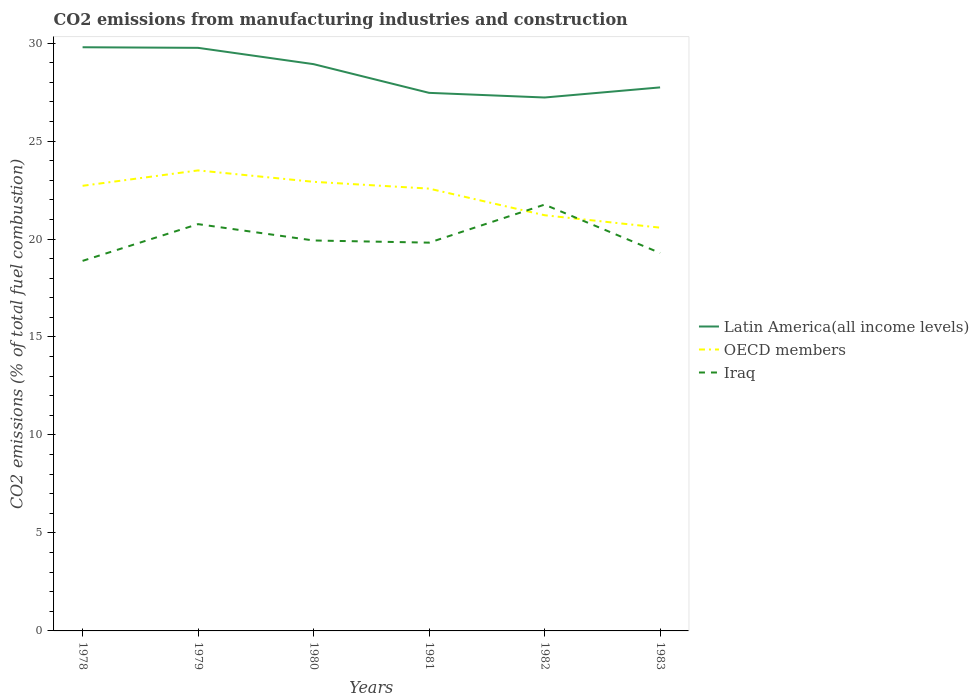Is the number of lines equal to the number of legend labels?
Keep it short and to the point. Yes. Across all years, what is the maximum amount of CO2 emitted in Iraq?
Offer a terse response. 18.89. In which year was the amount of CO2 emitted in Latin America(all income levels) maximum?
Give a very brief answer. 1982. What is the total amount of CO2 emitted in Latin America(all income levels) in the graph?
Provide a short and direct response. 0.83. What is the difference between the highest and the second highest amount of CO2 emitted in OECD members?
Offer a very short reply. 2.92. Is the amount of CO2 emitted in Latin America(all income levels) strictly greater than the amount of CO2 emitted in Iraq over the years?
Provide a short and direct response. No. How many years are there in the graph?
Provide a short and direct response. 6. How many legend labels are there?
Offer a very short reply. 3. How are the legend labels stacked?
Keep it short and to the point. Vertical. What is the title of the graph?
Your answer should be compact. CO2 emissions from manufacturing industries and construction. Does "St. Lucia" appear as one of the legend labels in the graph?
Your answer should be compact. No. What is the label or title of the X-axis?
Offer a terse response. Years. What is the label or title of the Y-axis?
Offer a very short reply. CO2 emissions (% of total fuel combustion). What is the CO2 emissions (% of total fuel combustion) of Latin America(all income levels) in 1978?
Your response must be concise. 29.79. What is the CO2 emissions (% of total fuel combustion) in OECD members in 1978?
Your answer should be compact. 22.72. What is the CO2 emissions (% of total fuel combustion) in Iraq in 1978?
Your answer should be compact. 18.89. What is the CO2 emissions (% of total fuel combustion) of Latin America(all income levels) in 1979?
Your answer should be very brief. 29.76. What is the CO2 emissions (% of total fuel combustion) of OECD members in 1979?
Provide a short and direct response. 23.5. What is the CO2 emissions (% of total fuel combustion) of Iraq in 1979?
Ensure brevity in your answer.  20.76. What is the CO2 emissions (% of total fuel combustion) in Latin America(all income levels) in 1980?
Make the answer very short. 28.92. What is the CO2 emissions (% of total fuel combustion) in OECD members in 1980?
Your response must be concise. 22.92. What is the CO2 emissions (% of total fuel combustion) of Iraq in 1980?
Keep it short and to the point. 19.93. What is the CO2 emissions (% of total fuel combustion) in Latin America(all income levels) in 1981?
Ensure brevity in your answer.  27.46. What is the CO2 emissions (% of total fuel combustion) in OECD members in 1981?
Provide a succinct answer. 22.57. What is the CO2 emissions (% of total fuel combustion) of Iraq in 1981?
Give a very brief answer. 19.82. What is the CO2 emissions (% of total fuel combustion) in Latin America(all income levels) in 1982?
Keep it short and to the point. 27.22. What is the CO2 emissions (% of total fuel combustion) of OECD members in 1982?
Your response must be concise. 21.21. What is the CO2 emissions (% of total fuel combustion) in Iraq in 1982?
Your answer should be compact. 21.76. What is the CO2 emissions (% of total fuel combustion) of Latin America(all income levels) in 1983?
Give a very brief answer. 27.74. What is the CO2 emissions (% of total fuel combustion) in OECD members in 1983?
Offer a very short reply. 20.58. What is the CO2 emissions (% of total fuel combustion) in Iraq in 1983?
Make the answer very short. 19.29. Across all years, what is the maximum CO2 emissions (% of total fuel combustion) in Latin America(all income levels)?
Provide a succinct answer. 29.79. Across all years, what is the maximum CO2 emissions (% of total fuel combustion) in OECD members?
Your response must be concise. 23.5. Across all years, what is the maximum CO2 emissions (% of total fuel combustion) of Iraq?
Give a very brief answer. 21.76. Across all years, what is the minimum CO2 emissions (% of total fuel combustion) of Latin America(all income levels)?
Make the answer very short. 27.22. Across all years, what is the minimum CO2 emissions (% of total fuel combustion) in OECD members?
Ensure brevity in your answer.  20.58. Across all years, what is the minimum CO2 emissions (% of total fuel combustion) of Iraq?
Keep it short and to the point. 18.89. What is the total CO2 emissions (% of total fuel combustion) of Latin America(all income levels) in the graph?
Offer a terse response. 170.89. What is the total CO2 emissions (% of total fuel combustion) of OECD members in the graph?
Provide a succinct answer. 133.51. What is the total CO2 emissions (% of total fuel combustion) of Iraq in the graph?
Give a very brief answer. 120.43. What is the difference between the CO2 emissions (% of total fuel combustion) of Latin America(all income levels) in 1978 and that in 1979?
Give a very brief answer. 0.03. What is the difference between the CO2 emissions (% of total fuel combustion) of OECD members in 1978 and that in 1979?
Your answer should be compact. -0.79. What is the difference between the CO2 emissions (% of total fuel combustion) of Iraq in 1978 and that in 1979?
Your answer should be very brief. -1.88. What is the difference between the CO2 emissions (% of total fuel combustion) in Latin America(all income levels) in 1978 and that in 1980?
Your answer should be very brief. 0.86. What is the difference between the CO2 emissions (% of total fuel combustion) in OECD members in 1978 and that in 1980?
Your response must be concise. -0.2. What is the difference between the CO2 emissions (% of total fuel combustion) in Iraq in 1978 and that in 1980?
Provide a succinct answer. -1.04. What is the difference between the CO2 emissions (% of total fuel combustion) in Latin America(all income levels) in 1978 and that in 1981?
Your answer should be very brief. 2.33. What is the difference between the CO2 emissions (% of total fuel combustion) of OECD members in 1978 and that in 1981?
Keep it short and to the point. 0.14. What is the difference between the CO2 emissions (% of total fuel combustion) of Iraq in 1978 and that in 1981?
Ensure brevity in your answer.  -0.93. What is the difference between the CO2 emissions (% of total fuel combustion) in Latin America(all income levels) in 1978 and that in 1982?
Offer a terse response. 2.56. What is the difference between the CO2 emissions (% of total fuel combustion) of OECD members in 1978 and that in 1982?
Your answer should be compact. 1.5. What is the difference between the CO2 emissions (% of total fuel combustion) in Iraq in 1978 and that in 1982?
Keep it short and to the point. -2.87. What is the difference between the CO2 emissions (% of total fuel combustion) of Latin America(all income levels) in 1978 and that in 1983?
Give a very brief answer. 2.05. What is the difference between the CO2 emissions (% of total fuel combustion) of OECD members in 1978 and that in 1983?
Your answer should be very brief. 2.14. What is the difference between the CO2 emissions (% of total fuel combustion) in Iraq in 1978 and that in 1983?
Make the answer very short. -0.4. What is the difference between the CO2 emissions (% of total fuel combustion) in Latin America(all income levels) in 1979 and that in 1980?
Provide a succinct answer. 0.83. What is the difference between the CO2 emissions (% of total fuel combustion) of OECD members in 1979 and that in 1980?
Ensure brevity in your answer.  0.58. What is the difference between the CO2 emissions (% of total fuel combustion) of Iraq in 1979 and that in 1980?
Your answer should be very brief. 0.83. What is the difference between the CO2 emissions (% of total fuel combustion) in Latin America(all income levels) in 1979 and that in 1981?
Make the answer very short. 2.3. What is the difference between the CO2 emissions (% of total fuel combustion) in OECD members in 1979 and that in 1981?
Give a very brief answer. 0.93. What is the difference between the CO2 emissions (% of total fuel combustion) in Iraq in 1979 and that in 1981?
Offer a very short reply. 0.94. What is the difference between the CO2 emissions (% of total fuel combustion) of Latin America(all income levels) in 1979 and that in 1982?
Your response must be concise. 2.53. What is the difference between the CO2 emissions (% of total fuel combustion) in OECD members in 1979 and that in 1982?
Keep it short and to the point. 2.29. What is the difference between the CO2 emissions (% of total fuel combustion) in Iraq in 1979 and that in 1982?
Provide a succinct answer. -1. What is the difference between the CO2 emissions (% of total fuel combustion) of Latin America(all income levels) in 1979 and that in 1983?
Make the answer very short. 2.02. What is the difference between the CO2 emissions (% of total fuel combustion) in OECD members in 1979 and that in 1983?
Your response must be concise. 2.92. What is the difference between the CO2 emissions (% of total fuel combustion) of Iraq in 1979 and that in 1983?
Offer a very short reply. 1.47. What is the difference between the CO2 emissions (% of total fuel combustion) in Latin America(all income levels) in 1980 and that in 1981?
Keep it short and to the point. 1.46. What is the difference between the CO2 emissions (% of total fuel combustion) in OECD members in 1980 and that in 1981?
Provide a short and direct response. 0.35. What is the difference between the CO2 emissions (% of total fuel combustion) of Iraq in 1980 and that in 1981?
Keep it short and to the point. 0.11. What is the difference between the CO2 emissions (% of total fuel combustion) in Latin America(all income levels) in 1980 and that in 1982?
Give a very brief answer. 1.7. What is the difference between the CO2 emissions (% of total fuel combustion) in OECD members in 1980 and that in 1982?
Your answer should be compact. 1.71. What is the difference between the CO2 emissions (% of total fuel combustion) in Iraq in 1980 and that in 1982?
Provide a short and direct response. -1.83. What is the difference between the CO2 emissions (% of total fuel combustion) in Latin America(all income levels) in 1980 and that in 1983?
Give a very brief answer. 1.19. What is the difference between the CO2 emissions (% of total fuel combustion) in OECD members in 1980 and that in 1983?
Give a very brief answer. 2.34. What is the difference between the CO2 emissions (% of total fuel combustion) of Iraq in 1980 and that in 1983?
Offer a terse response. 0.64. What is the difference between the CO2 emissions (% of total fuel combustion) of Latin America(all income levels) in 1981 and that in 1982?
Your response must be concise. 0.24. What is the difference between the CO2 emissions (% of total fuel combustion) of OECD members in 1981 and that in 1982?
Give a very brief answer. 1.36. What is the difference between the CO2 emissions (% of total fuel combustion) of Iraq in 1981 and that in 1982?
Your answer should be compact. -1.94. What is the difference between the CO2 emissions (% of total fuel combustion) in Latin America(all income levels) in 1981 and that in 1983?
Make the answer very short. -0.28. What is the difference between the CO2 emissions (% of total fuel combustion) of OECD members in 1981 and that in 1983?
Make the answer very short. 1.99. What is the difference between the CO2 emissions (% of total fuel combustion) of Iraq in 1981 and that in 1983?
Give a very brief answer. 0.53. What is the difference between the CO2 emissions (% of total fuel combustion) of Latin America(all income levels) in 1982 and that in 1983?
Provide a short and direct response. -0.52. What is the difference between the CO2 emissions (% of total fuel combustion) in OECD members in 1982 and that in 1983?
Make the answer very short. 0.63. What is the difference between the CO2 emissions (% of total fuel combustion) of Iraq in 1982 and that in 1983?
Offer a terse response. 2.47. What is the difference between the CO2 emissions (% of total fuel combustion) in Latin America(all income levels) in 1978 and the CO2 emissions (% of total fuel combustion) in OECD members in 1979?
Make the answer very short. 6.29. What is the difference between the CO2 emissions (% of total fuel combustion) of Latin America(all income levels) in 1978 and the CO2 emissions (% of total fuel combustion) of Iraq in 1979?
Your answer should be compact. 9.03. What is the difference between the CO2 emissions (% of total fuel combustion) of OECD members in 1978 and the CO2 emissions (% of total fuel combustion) of Iraq in 1979?
Your answer should be very brief. 1.96. What is the difference between the CO2 emissions (% of total fuel combustion) in Latin America(all income levels) in 1978 and the CO2 emissions (% of total fuel combustion) in OECD members in 1980?
Keep it short and to the point. 6.87. What is the difference between the CO2 emissions (% of total fuel combustion) in Latin America(all income levels) in 1978 and the CO2 emissions (% of total fuel combustion) in Iraq in 1980?
Provide a succinct answer. 9.86. What is the difference between the CO2 emissions (% of total fuel combustion) of OECD members in 1978 and the CO2 emissions (% of total fuel combustion) of Iraq in 1980?
Make the answer very short. 2.79. What is the difference between the CO2 emissions (% of total fuel combustion) of Latin America(all income levels) in 1978 and the CO2 emissions (% of total fuel combustion) of OECD members in 1981?
Ensure brevity in your answer.  7.21. What is the difference between the CO2 emissions (% of total fuel combustion) in Latin America(all income levels) in 1978 and the CO2 emissions (% of total fuel combustion) in Iraq in 1981?
Give a very brief answer. 9.97. What is the difference between the CO2 emissions (% of total fuel combustion) of OECD members in 1978 and the CO2 emissions (% of total fuel combustion) of Iraq in 1981?
Your response must be concise. 2.9. What is the difference between the CO2 emissions (% of total fuel combustion) in Latin America(all income levels) in 1978 and the CO2 emissions (% of total fuel combustion) in OECD members in 1982?
Make the answer very short. 8.57. What is the difference between the CO2 emissions (% of total fuel combustion) of Latin America(all income levels) in 1978 and the CO2 emissions (% of total fuel combustion) of Iraq in 1982?
Provide a succinct answer. 8.03. What is the difference between the CO2 emissions (% of total fuel combustion) of OECD members in 1978 and the CO2 emissions (% of total fuel combustion) of Iraq in 1982?
Your response must be concise. 0.96. What is the difference between the CO2 emissions (% of total fuel combustion) of Latin America(all income levels) in 1978 and the CO2 emissions (% of total fuel combustion) of OECD members in 1983?
Offer a very short reply. 9.21. What is the difference between the CO2 emissions (% of total fuel combustion) of Latin America(all income levels) in 1978 and the CO2 emissions (% of total fuel combustion) of Iraq in 1983?
Give a very brief answer. 10.5. What is the difference between the CO2 emissions (% of total fuel combustion) in OECD members in 1978 and the CO2 emissions (% of total fuel combustion) in Iraq in 1983?
Ensure brevity in your answer.  3.43. What is the difference between the CO2 emissions (% of total fuel combustion) in Latin America(all income levels) in 1979 and the CO2 emissions (% of total fuel combustion) in OECD members in 1980?
Offer a terse response. 6.84. What is the difference between the CO2 emissions (% of total fuel combustion) in Latin America(all income levels) in 1979 and the CO2 emissions (% of total fuel combustion) in Iraq in 1980?
Offer a terse response. 9.83. What is the difference between the CO2 emissions (% of total fuel combustion) in OECD members in 1979 and the CO2 emissions (% of total fuel combustion) in Iraq in 1980?
Your answer should be compact. 3.58. What is the difference between the CO2 emissions (% of total fuel combustion) in Latin America(all income levels) in 1979 and the CO2 emissions (% of total fuel combustion) in OECD members in 1981?
Make the answer very short. 7.18. What is the difference between the CO2 emissions (% of total fuel combustion) in Latin America(all income levels) in 1979 and the CO2 emissions (% of total fuel combustion) in Iraq in 1981?
Your answer should be very brief. 9.94. What is the difference between the CO2 emissions (% of total fuel combustion) of OECD members in 1979 and the CO2 emissions (% of total fuel combustion) of Iraq in 1981?
Offer a very short reply. 3.69. What is the difference between the CO2 emissions (% of total fuel combustion) of Latin America(all income levels) in 1979 and the CO2 emissions (% of total fuel combustion) of OECD members in 1982?
Your response must be concise. 8.54. What is the difference between the CO2 emissions (% of total fuel combustion) in Latin America(all income levels) in 1979 and the CO2 emissions (% of total fuel combustion) in Iraq in 1982?
Give a very brief answer. 8. What is the difference between the CO2 emissions (% of total fuel combustion) in OECD members in 1979 and the CO2 emissions (% of total fuel combustion) in Iraq in 1982?
Provide a succinct answer. 1.75. What is the difference between the CO2 emissions (% of total fuel combustion) in Latin America(all income levels) in 1979 and the CO2 emissions (% of total fuel combustion) in OECD members in 1983?
Make the answer very short. 9.18. What is the difference between the CO2 emissions (% of total fuel combustion) in Latin America(all income levels) in 1979 and the CO2 emissions (% of total fuel combustion) in Iraq in 1983?
Your response must be concise. 10.47. What is the difference between the CO2 emissions (% of total fuel combustion) of OECD members in 1979 and the CO2 emissions (% of total fuel combustion) of Iraq in 1983?
Provide a succinct answer. 4.21. What is the difference between the CO2 emissions (% of total fuel combustion) of Latin America(all income levels) in 1980 and the CO2 emissions (% of total fuel combustion) of OECD members in 1981?
Make the answer very short. 6.35. What is the difference between the CO2 emissions (% of total fuel combustion) of Latin America(all income levels) in 1980 and the CO2 emissions (% of total fuel combustion) of Iraq in 1981?
Provide a succinct answer. 9.11. What is the difference between the CO2 emissions (% of total fuel combustion) of OECD members in 1980 and the CO2 emissions (% of total fuel combustion) of Iraq in 1981?
Give a very brief answer. 3.1. What is the difference between the CO2 emissions (% of total fuel combustion) of Latin America(all income levels) in 1980 and the CO2 emissions (% of total fuel combustion) of OECD members in 1982?
Give a very brief answer. 7.71. What is the difference between the CO2 emissions (% of total fuel combustion) in Latin America(all income levels) in 1980 and the CO2 emissions (% of total fuel combustion) in Iraq in 1982?
Make the answer very short. 7.17. What is the difference between the CO2 emissions (% of total fuel combustion) in OECD members in 1980 and the CO2 emissions (% of total fuel combustion) in Iraq in 1982?
Provide a short and direct response. 1.16. What is the difference between the CO2 emissions (% of total fuel combustion) of Latin America(all income levels) in 1980 and the CO2 emissions (% of total fuel combustion) of OECD members in 1983?
Give a very brief answer. 8.34. What is the difference between the CO2 emissions (% of total fuel combustion) of Latin America(all income levels) in 1980 and the CO2 emissions (% of total fuel combustion) of Iraq in 1983?
Offer a terse response. 9.64. What is the difference between the CO2 emissions (% of total fuel combustion) of OECD members in 1980 and the CO2 emissions (% of total fuel combustion) of Iraq in 1983?
Offer a very short reply. 3.63. What is the difference between the CO2 emissions (% of total fuel combustion) of Latin America(all income levels) in 1981 and the CO2 emissions (% of total fuel combustion) of OECD members in 1982?
Your answer should be very brief. 6.25. What is the difference between the CO2 emissions (% of total fuel combustion) of Latin America(all income levels) in 1981 and the CO2 emissions (% of total fuel combustion) of Iraq in 1982?
Offer a very short reply. 5.7. What is the difference between the CO2 emissions (% of total fuel combustion) in OECD members in 1981 and the CO2 emissions (% of total fuel combustion) in Iraq in 1982?
Give a very brief answer. 0.82. What is the difference between the CO2 emissions (% of total fuel combustion) of Latin America(all income levels) in 1981 and the CO2 emissions (% of total fuel combustion) of OECD members in 1983?
Ensure brevity in your answer.  6.88. What is the difference between the CO2 emissions (% of total fuel combustion) of Latin America(all income levels) in 1981 and the CO2 emissions (% of total fuel combustion) of Iraq in 1983?
Ensure brevity in your answer.  8.17. What is the difference between the CO2 emissions (% of total fuel combustion) in OECD members in 1981 and the CO2 emissions (% of total fuel combustion) in Iraq in 1983?
Give a very brief answer. 3.29. What is the difference between the CO2 emissions (% of total fuel combustion) of Latin America(all income levels) in 1982 and the CO2 emissions (% of total fuel combustion) of OECD members in 1983?
Make the answer very short. 6.64. What is the difference between the CO2 emissions (% of total fuel combustion) in Latin America(all income levels) in 1982 and the CO2 emissions (% of total fuel combustion) in Iraq in 1983?
Make the answer very short. 7.93. What is the difference between the CO2 emissions (% of total fuel combustion) of OECD members in 1982 and the CO2 emissions (% of total fuel combustion) of Iraq in 1983?
Ensure brevity in your answer.  1.93. What is the average CO2 emissions (% of total fuel combustion) in Latin America(all income levels) per year?
Offer a terse response. 28.48. What is the average CO2 emissions (% of total fuel combustion) of OECD members per year?
Provide a short and direct response. 22.25. What is the average CO2 emissions (% of total fuel combustion) of Iraq per year?
Provide a short and direct response. 20.07. In the year 1978, what is the difference between the CO2 emissions (% of total fuel combustion) of Latin America(all income levels) and CO2 emissions (% of total fuel combustion) of OECD members?
Provide a succinct answer. 7.07. In the year 1978, what is the difference between the CO2 emissions (% of total fuel combustion) in Latin America(all income levels) and CO2 emissions (% of total fuel combustion) in Iraq?
Your answer should be very brief. 10.9. In the year 1978, what is the difference between the CO2 emissions (% of total fuel combustion) of OECD members and CO2 emissions (% of total fuel combustion) of Iraq?
Ensure brevity in your answer.  3.83. In the year 1979, what is the difference between the CO2 emissions (% of total fuel combustion) of Latin America(all income levels) and CO2 emissions (% of total fuel combustion) of OECD members?
Offer a very short reply. 6.25. In the year 1979, what is the difference between the CO2 emissions (% of total fuel combustion) of Latin America(all income levels) and CO2 emissions (% of total fuel combustion) of Iraq?
Give a very brief answer. 9. In the year 1979, what is the difference between the CO2 emissions (% of total fuel combustion) in OECD members and CO2 emissions (% of total fuel combustion) in Iraq?
Offer a very short reply. 2.74. In the year 1980, what is the difference between the CO2 emissions (% of total fuel combustion) of Latin America(all income levels) and CO2 emissions (% of total fuel combustion) of OECD members?
Provide a short and direct response. 6. In the year 1980, what is the difference between the CO2 emissions (% of total fuel combustion) of Latin America(all income levels) and CO2 emissions (% of total fuel combustion) of Iraq?
Ensure brevity in your answer.  9. In the year 1980, what is the difference between the CO2 emissions (% of total fuel combustion) of OECD members and CO2 emissions (% of total fuel combustion) of Iraq?
Offer a terse response. 2.99. In the year 1981, what is the difference between the CO2 emissions (% of total fuel combustion) of Latin America(all income levels) and CO2 emissions (% of total fuel combustion) of OECD members?
Your answer should be very brief. 4.89. In the year 1981, what is the difference between the CO2 emissions (% of total fuel combustion) in Latin America(all income levels) and CO2 emissions (% of total fuel combustion) in Iraq?
Give a very brief answer. 7.64. In the year 1981, what is the difference between the CO2 emissions (% of total fuel combustion) of OECD members and CO2 emissions (% of total fuel combustion) of Iraq?
Provide a short and direct response. 2.76. In the year 1982, what is the difference between the CO2 emissions (% of total fuel combustion) in Latin America(all income levels) and CO2 emissions (% of total fuel combustion) in OECD members?
Your answer should be compact. 6.01. In the year 1982, what is the difference between the CO2 emissions (% of total fuel combustion) of Latin America(all income levels) and CO2 emissions (% of total fuel combustion) of Iraq?
Your answer should be compact. 5.47. In the year 1982, what is the difference between the CO2 emissions (% of total fuel combustion) in OECD members and CO2 emissions (% of total fuel combustion) in Iraq?
Keep it short and to the point. -0.54. In the year 1983, what is the difference between the CO2 emissions (% of total fuel combustion) of Latin America(all income levels) and CO2 emissions (% of total fuel combustion) of OECD members?
Give a very brief answer. 7.16. In the year 1983, what is the difference between the CO2 emissions (% of total fuel combustion) in Latin America(all income levels) and CO2 emissions (% of total fuel combustion) in Iraq?
Your answer should be compact. 8.45. In the year 1983, what is the difference between the CO2 emissions (% of total fuel combustion) of OECD members and CO2 emissions (% of total fuel combustion) of Iraq?
Offer a very short reply. 1.29. What is the ratio of the CO2 emissions (% of total fuel combustion) of OECD members in 1978 to that in 1979?
Provide a short and direct response. 0.97. What is the ratio of the CO2 emissions (% of total fuel combustion) in Iraq in 1978 to that in 1979?
Provide a short and direct response. 0.91. What is the ratio of the CO2 emissions (% of total fuel combustion) of Latin America(all income levels) in 1978 to that in 1980?
Provide a succinct answer. 1.03. What is the ratio of the CO2 emissions (% of total fuel combustion) of OECD members in 1978 to that in 1980?
Provide a succinct answer. 0.99. What is the ratio of the CO2 emissions (% of total fuel combustion) in Iraq in 1978 to that in 1980?
Give a very brief answer. 0.95. What is the ratio of the CO2 emissions (% of total fuel combustion) of Latin America(all income levels) in 1978 to that in 1981?
Offer a terse response. 1.08. What is the ratio of the CO2 emissions (% of total fuel combustion) in OECD members in 1978 to that in 1981?
Provide a short and direct response. 1.01. What is the ratio of the CO2 emissions (% of total fuel combustion) in Iraq in 1978 to that in 1981?
Provide a short and direct response. 0.95. What is the ratio of the CO2 emissions (% of total fuel combustion) of Latin America(all income levels) in 1978 to that in 1982?
Provide a succinct answer. 1.09. What is the ratio of the CO2 emissions (% of total fuel combustion) in OECD members in 1978 to that in 1982?
Keep it short and to the point. 1.07. What is the ratio of the CO2 emissions (% of total fuel combustion) in Iraq in 1978 to that in 1982?
Your response must be concise. 0.87. What is the ratio of the CO2 emissions (% of total fuel combustion) of Latin America(all income levels) in 1978 to that in 1983?
Give a very brief answer. 1.07. What is the ratio of the CO2 emissions (% of total fuel combustion) of OECD members in 1978 to that in 1983?
Your answer should be compact. 1.1. What is the ratio of the CO2 emissions (% of total fuel combustion) of Iraq in 1978 to that in 1983?
Give a very brief answer. 0.98. What is the ratio of the CO2 emissions (% of total fuel combustion) of Latin America(all income levels) in 1979 to that in 1980?
Your answer should be very brief. 1.03. What is the ratio of the CO2 emissions (% of total fuel combustion) of OECD members in 1979 to that in 1980?
Your answer should be very brief. 1.03. What is the ratio of the CO2 emissions (% of total fuel combustion) of Iraq in 1979 to that in 1980?
Ensure brevity in your answer.  1.04. What is the ratio of the CO2 emissions (% of total fuel combustion) of Latin America(all income levels) in 1979 to that in 1981?
Ensure brevity in your answer.  1.08. What is the ratio of the CO2 emissions (% of total fuel combustion) of OECD members in 1979 to that in 1981?
Your response must be concise. 1.04. What is the ratio of the CO2 emissions (% of total fuel combustion) in Iraq in 1979 to that in 1981?
Ensure brevity in your answer.  1.05. What is the ratio of the CO2 emissions (% of total fuel combustion) in Latin America(all income levels) in 1979 to that in 1982?
Give a very brief answer. 1.09. What is the ratio of the CO2 emissions (% of total fuel combustion) of OECD members in 1979 to that in 1982?
Offer a terse response. 1.11. What is the ratio of the CO2 emissions (% of total fuel combustion) of Iraq in 1979 to that in 1982?
Your response must be concise. 0.95. What is the ratio of the CO2 emissions (% of total fuel combustion) in Latin America(all income levels) in 1979 to that in 1983?
Your answer should be very brief. 1.07. What is the ratio of the CO2 emissions (% of total fuel combustion) of OECD members in 1979 to that in 1983?
Your answer should be compact. 1.14. What is the ratio of the CO2 emissions (% of total fuel combustion) in Iraq in 1979 to that in 1983?
Provide a short and direct response. 1.08. What is the ratio of the CO2 emissions (% of total fuel combustion) of Latin America(all income levels) in 1980 to that in 1981?
Your answer should be compact. 1.05. What is the ratio of the CO2 emissions (% of total fuel combustion) in OECD members in 1980 to that in 1981?
Offer a terse response. 1.02. What is the ratio of the CO2 emissions (% of total fuel combustion) in Iraq in 1980 to that in 1981?
Your response must be concise. 1.01. What is the ratio of the CO2 emissions (% of total fuel combustion) of OECD members in 1980 to that in 1982?
Your answer should be very brief. 1.08. What is the ratio of the CO2 emissions (% of total fuel combustion) of Iraq in 1980 to that in 1982?
Offer a very short reply. 0.92. What is the ratio of the CO2 emissions (% of total fuel combustion) in Latin America(all income levels) in 1980 to that in 1983?
Provide a short and direct response. 1.04. What is the ratio of the CO2 emissions (% of total fuel combustion) of OECD members in 1980 to that in 1983?
Offer a terse response. 1.11. What is the ratio of the CO2 emissions (% of total fuel combustion) of Iraq in 1980 to that in 1983?
Keep it short and to the point. 1.03. What is the ratio of the CO2 emissions (% of total fuel combustion) of Latin America(all income levels) in 1981 to that in 1982?
Your response must be concise. 1.01. What is the ratio of the CO2 emissions (% of total fuel combustion) in OECD members in 1981 to that in 1982?
Keep it short and to the point. 1.06. What is the ratio of the CO2 emissions (% of total fuel combustion) of Iraq in 1981 to that in 1982?
Provide a short and direct response. 0.91. What is the ratio of the CO2 emissions (% of total fuel combustion) in Latin America(all income levels) in 1981 to that in 1983?
Provide a short and direct response. 0.99. What is the ratio of the CO2 emissions (% of total fuel combustion) in OECD members in 1981 to that in 1983?
Your answer should be very brief. 1.1. What is the ratio of the CO2 emissions (% of total fuel combustion) of Iraq in 1981 to that in 1983?
Give a very brief answer. 1.03. What is the ratio of the CO2 emissions (% of total fuel combustion) of Latin America(all income levels) in 1982 to that in 1983?
Offer a terse response. 0.98. What is the ratio of the CO2 emissions (% of total fuel combustion) of OECD members in 1982 to that in 1983?
Make the answer very short. 1.03. What is the ratio of the CO2 emissions (% of total fuel combustion) in Iraq in 1982 to that in 1983?
Give a very brief answer. 1.13. What is the difference between the highest and the second highest CO2 emissions (% of total fuel combustion) in Latin America(all income levels)?
Your response must be concise. 0.03. What is the difference between the highest and the second highest CO2 emissions (% of total fuel combustion) in OECD members?
Offer a terse response. 0.58. What is the difference between the highest and the lowest CO2 emissions (% of total fuel combustion) in Latin America(all income levels)?
Offer a terse response. 2.56. What is the difference between the highest and the lowest CO2 emissions (% of total fuel combustion) of OECD members?
Offer a terse response. 2.92. What is the difference between the highest and the lowest CO2 emissions (% of total fuel combustion) in Iraq?
Give a very brief answer. 2.87. 